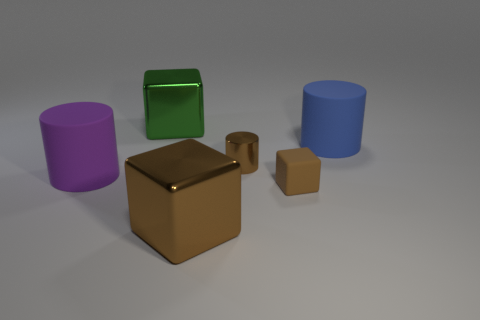Is the number of tiny metal cylinders on the left side of the large purple matte object less than the number of metallic objects behind the big blue object?
Offer a terse response. Yes. What is the size of the cube that is both in front of the green metallic thing and left of the tiny cube?
Your answer should be very brief. Large. Are there any shiny cylinders right of the large matte object that is on the right side of the big metallic cube behind the brown metal cylinder?
Ensure brevity in your answer.  No. Are any tiny brown rubber cylinders visible?
Keep it short and to the point. No. Is the number of tiny brown matte objects that are behind the purple matte object greater than the number of green objects on the left side of the large blue matte object?
Give a very brief answer. No. There is a brown thing that is the same material as the purple object; what is its size?
Provide a short and direct response. Small. There is a brown metal cylinder right of the large block in front of the big cylinder right of the purple matte object; how big is it?
Offer a terse response. Small. What is the color of the cylinder on the right side of the small metallic object?
Offer a very short reply. Blue. Are there more rubber cylinders that are right of the large blue matte cylinder than large objects?
Offer a very short reply. No. There is a big metal thing in front of the brown matte thing; does it have the same shape as the large blue thing?
Your answer should be compact. No. 